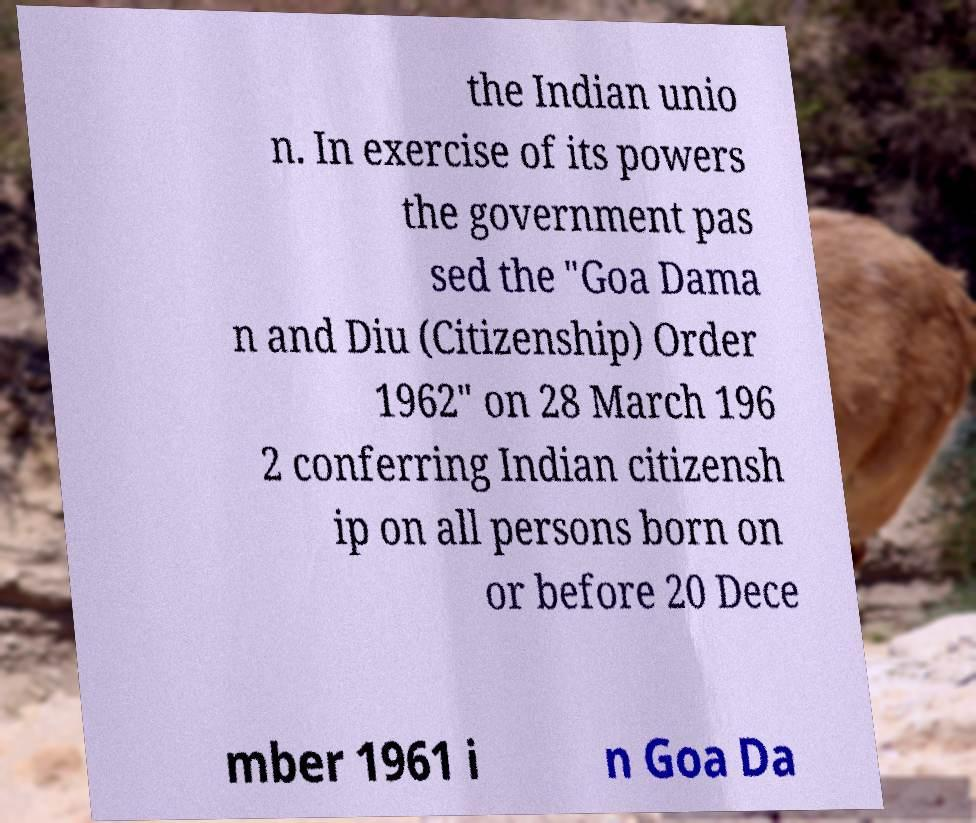What messages or text are displayed in this image? I need them in a readable, typed format. the Indian unio n. In exercise of its powers the government pas sed the "Goa Dama n and Diu (Citizenship) Order 1962" on 28 March 196 2 conferring Indian citizensh ip on all persons born on or before 20 Dece mber 1961 i n Goa Da 